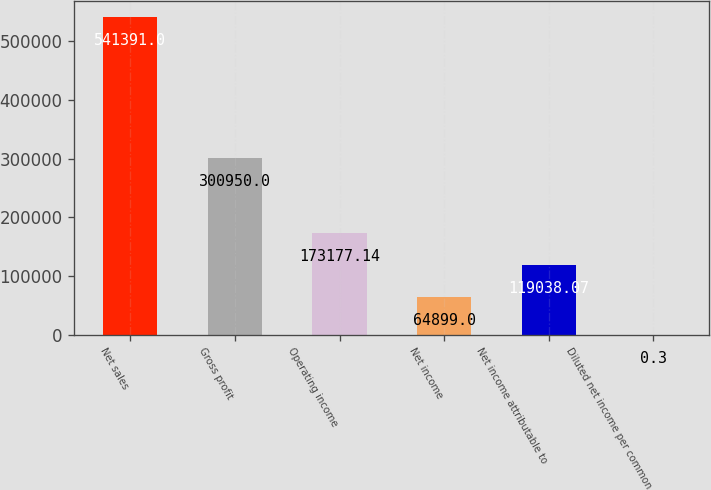<chart> <loc_0><loc_0><loc_500><loc_500><bar_chart><fcel>Net sales<fcel>Gross profit<fcel>Operating income<fcel>Net income<fcel>Net income attributable to<fcel>Diluted net income per common<nl><fcel>541391<fcel>300950<fcel>173177<fcel>64899<fcel>119038<fcel>0.3<nl></chart> 